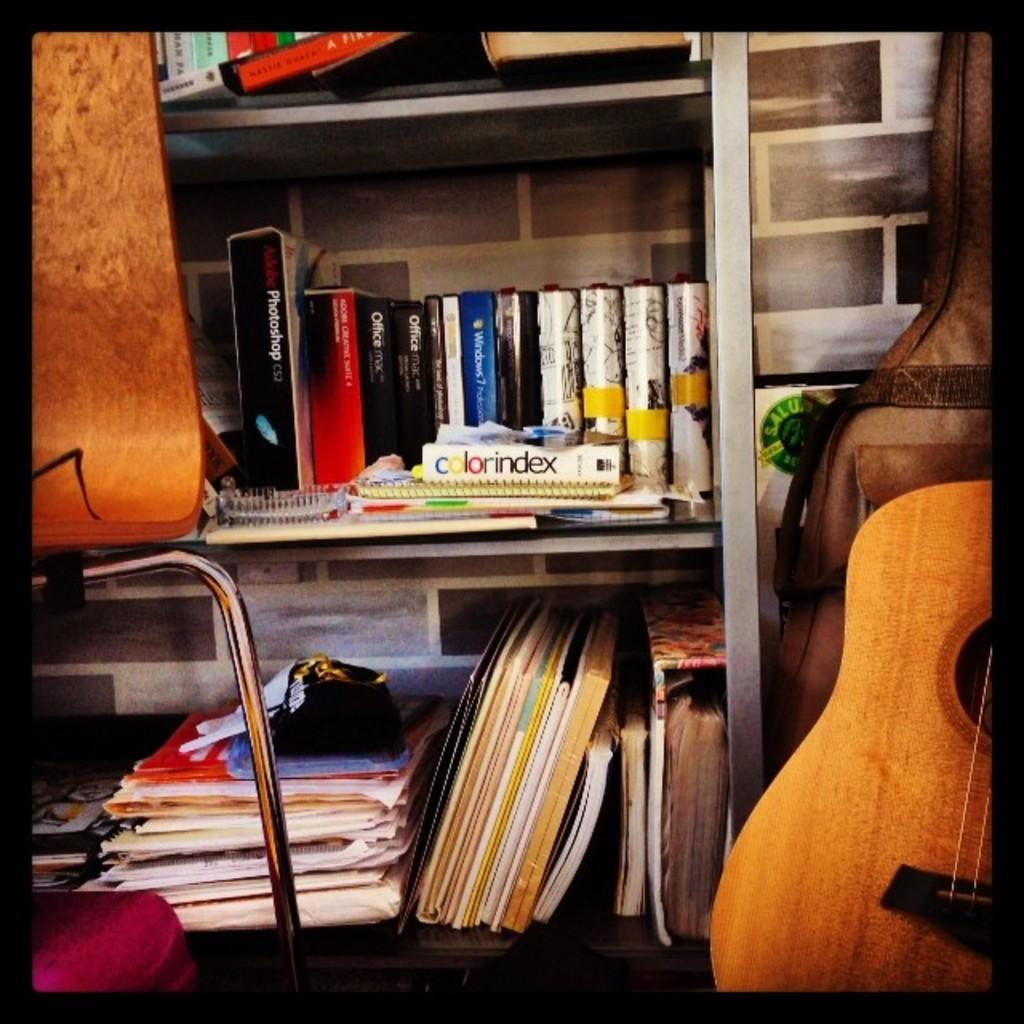<image>
Render a clear and concise summary of the photo. A shelf with various books including colorindex and a guitar beside it. 